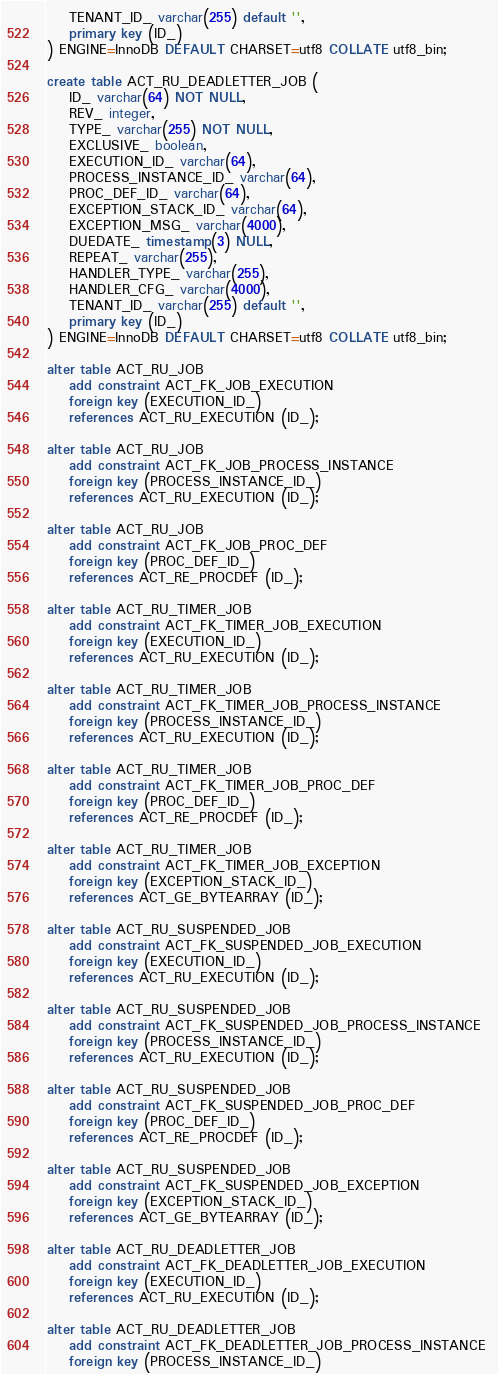<code> <loc_0><loc_0><loc_500><loc_500><_SQL_>    TENANT_ID_ varchar(255) default '',
    primary key (ID_)
) ENGINE=InnoDB DEFAULT CHARSET=utf8 COLLATE utf8_bin;

create table ACT_RU_DEADLETTER_JOB (
    ID_ varchar(64) NOT NULL,
    REV_ integer,
    TYPE_ varchar(255) NOT NULL,
    EXCLUSIVE_ boolean,
    EXECUTION_ID_ varchar(64),
    PROCESS_INSTANCE_ID_ varchar(64),
    PROC_DEF_ID_ varchar(64),
    EXCEPTION_STACK_ID_ varchar(64),
    EXCEPTION_MSG_ varchar(4000),
    DUEDATE_ timestamp(3) NULL,
    REPEAT_ varchar(255),
    HANDLER_TYPE_ varchar(255),
    HANDLER_CFG_ varchar(4000),
    TENANT_ID_ varchar(255) default '',
    primary key (ID_)
) ENGINE=InnoDB DEFAULT CHARSET=utf8 COLLATE utf8_bin;

alter table ACT_RU_JOB 
    add constraint ACT_FK_JOB_EXECUTION 
    foreign key (EXECUTION_ID_) 
    references ACT_RU_EXECUTION (ID_);
    
alter table ACT_RU_JOB 
    add constraint ACT_FK_JOB_PROCESS_INSTANCE 
    foreign key (PROCESS_INSTANCE_ID_) 
    references ACT_RU_EXECUTION (ID_);
    
alter table ACT_RU_JOB 
    add constraint ACT_FK_JOB_PROC_DEF
    foreign key (PROC_DEF_ID_) 
    references ACT_RE_PROCDEF (ID_);
    
alter table ACT_RU_TIMER_JOB 
    add constraint ACT_FK_TIMER_JOB_EXECUTION 
    foreign key (EXECUTION_ID_) 
    references ACT_RU_EXECUTION (ID_);
    
alter table ACT_RU_TIMER_JOB 
    add constraint ACT_FK_TIMER_JOB_PROCESS_INSTANCE 
    foreign key (PROCESS_INSTANCE_ID_) 
    references ACT_RU_EXECUTION (ID_);
    
alter table ACT_RU_TIMER_JOB 
    add constraint ACT_FK_TIMER_JOB_PROC_DEF
    foreign key (PROC_DEF_ID_) 
    references ACT_RE_PROCDEF (ID_);
    
alter table ACT_RU_TIMER_JOB 
    add constraint ACT_FK_TIMER_JOB_EXCEPTION 
    foreign key (EXCEPTION_STACK_ID_) 
    references ACT_GE_BYTEARRAY (ID_);
    
alter table ACT_RU_SUSPENDED_JOB 
    add constraint ACT_FK_SUSPENDED_JOB_EXECUTION 
    foreign key (EXECUTION_ID_) 
    references ACT_RU_EXECUTION (ID_);
    
alter table ACT_RU_SUSPENDED_JOB 
    add constraint ACT_FK_SUSPENDED_JOB_PROCESS_INSTANCE 
    foreign key (PROCESS_INSTANCE_ID_) 
    references ACT_RU_EXECUTION (ID_);
    
alter table ACT_RU_SUSPENDED_JOB 
    add constraint ACT_FK_SUSPENDED_JOB_PROC_DEF
    foreign key (PROC_DEF_ID_) 
    references ACT_RE_PROCDEF (ID_);
    
alter table ACT_RU_SUSPENDED_JOB 
    add constraint ACT_FK_SUSPENDED_JOB_EXCEPTION 
    foreign key (EXCEPTION_STACK_ID_) 
    references ACT_GE_BYTEARRAY (ID_);
    
alter table ACT_RU_DEADLETTER_JOB 
    add constraint ACT_FK_DEADLETTER_JOB_EXECUTION 
    foreign key (EXECUTION_ID_) 
    references ACT_RU_EXECUTION (ID_);
    
alter table ACT_RU_DEADLETTER_JOB 
    add constraint ACT_FK_DEADLETTER_JOB_PROCESS_INSTANCE 
    foreign key (PROCESS_INSTANCE_ID_) </code> 